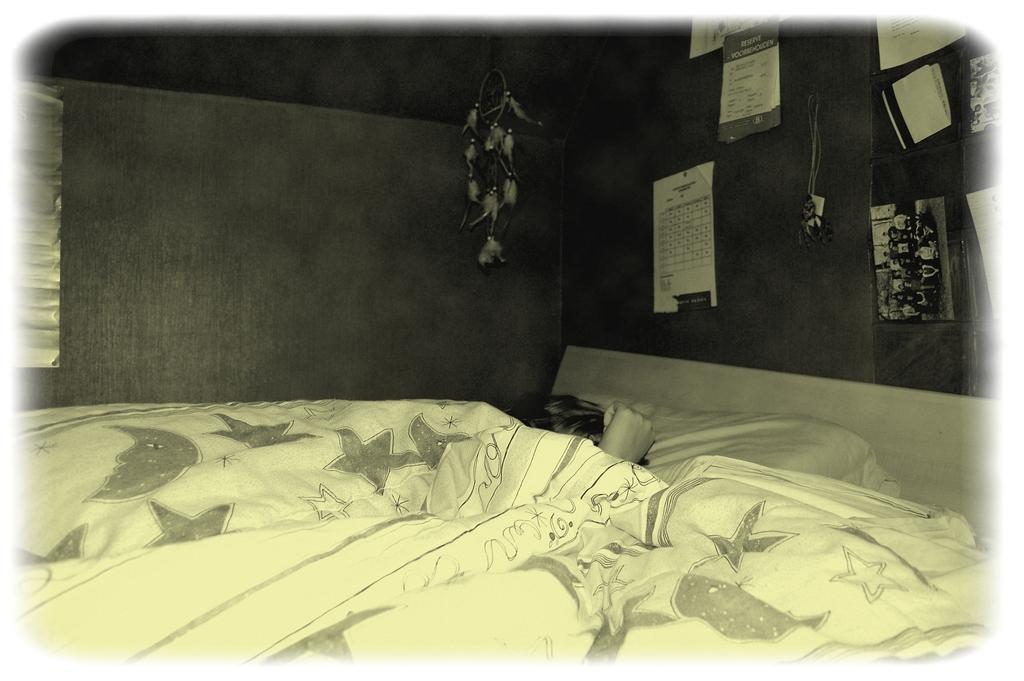How would you summarize this image in a sentence or two? In this image I can see a bed, a bed sheet and a person sleeping on the bed. In the background I can see a wall, few posters attached to the wall, a photo frame and an object hanged to the wall. 